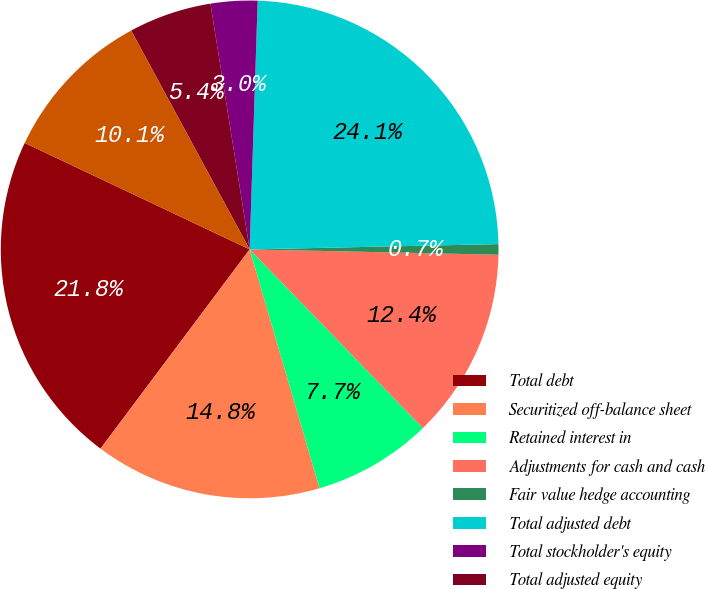Convert chart. <chart><loc_0><loc_0><loc_500><loc_500><pie_chart><fcel>Total debt<fcel>Securitized off-balance sheet<fcel>Retained interest in<fcel>Adjustments for cash and cash<fcel>Fair value hedge accounting<fcel>Total adjusted debt<fcel>Total stockholder's equity<fcel>Total adjusted equity<fcel>Managed debt-to-equity ratio<nl><fcel>21.81%<fcel>14.76%<fcel>7.72%<fcel>12.41%<fcel>0.68%<fcel>24.15%<fcel>3.03%<fcel>5.38%<fcel>10.07%<nl></chart> 